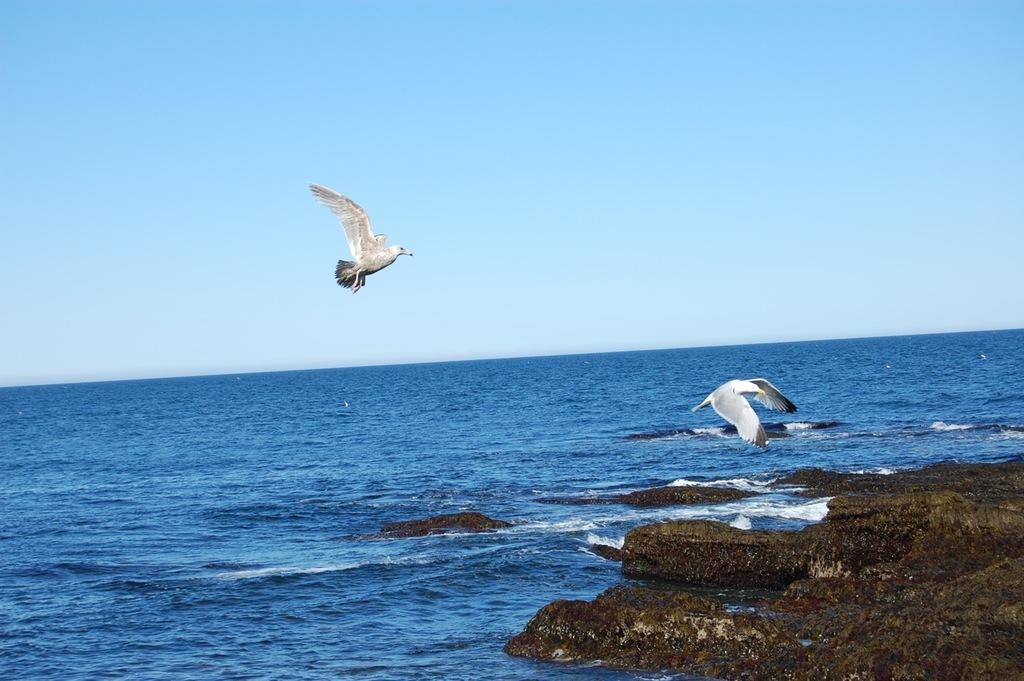What is the main feature in the middle of the image? There is an ocean in the middle of the image. What can be seen in the sky in the image? There are two birds flying in the sky. What type of objects are located on the right side bottom of the image? There are stones on the right side bottom of the image. What activity is the person performing with the rake in the image? There is no person or rake present in the image. 